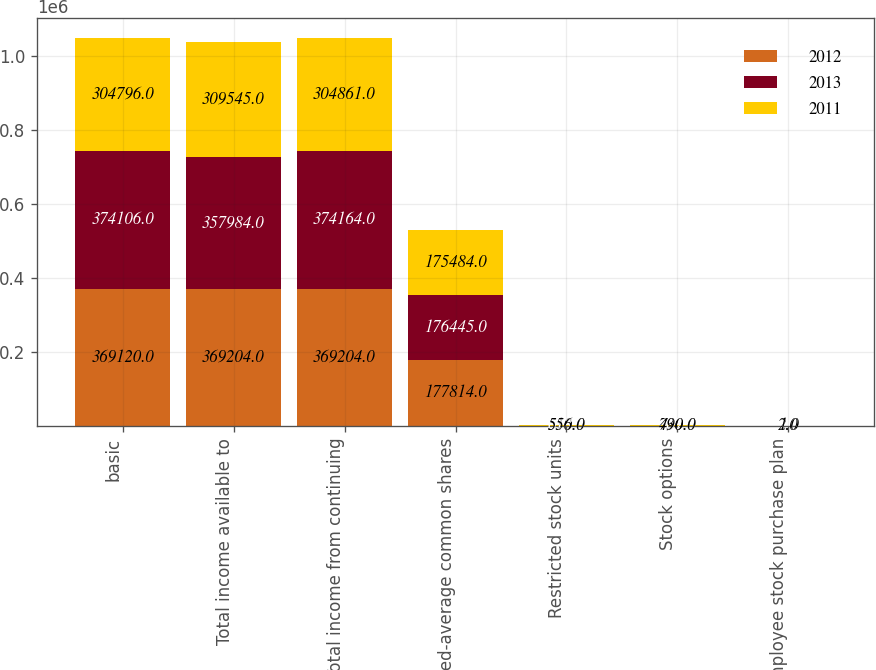Convert chart. <chart><loc_0><loc_0><loc_500><loc_500><stacked_bar_chart><ecel><fcel>basic<fcel>Total income available to<fcel>Total income from continuing<fcel>Weighted-average common shares<fcel>Restricted stock units<fcel>Stock options<fcel>Employee stock purchase plan<nl><fcel>2012<fcel>369120<fcel>369204<fcel>369204<fcel>177814<fcel>510<fcel>730<fcel>2<nl><fcel>2013<fcel>374106<fcel>357984<fcel>374164<fcel>176445<fcel>618<fcel>607<fcel>1<nl><fcel>2011<fcel>304796<fcel>309545<fcel>304861<fcel>175484<fcel>556<fcel>490<fcel>1<nl></chart> 